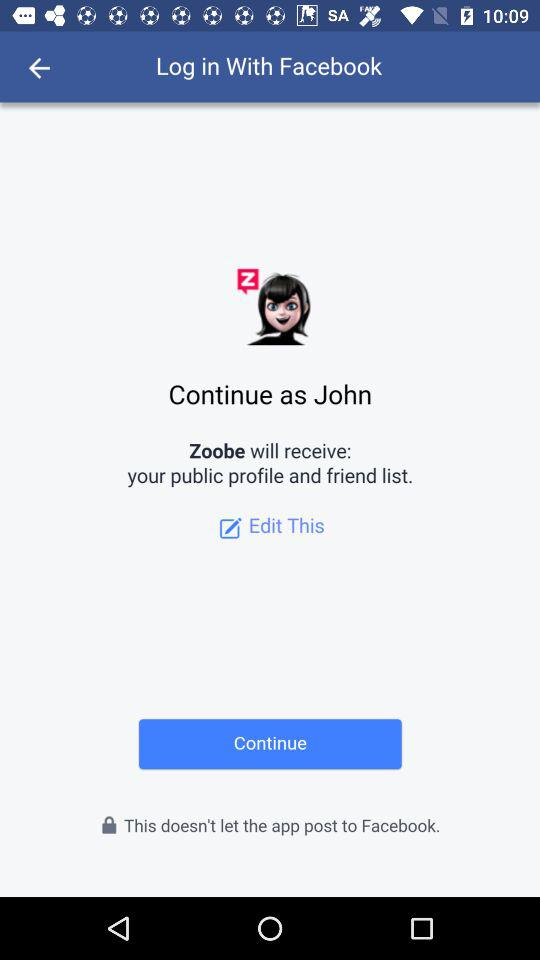Who will receive my public profile and friend list? The app that will receive your public profile and friend list is "Zoobe". 